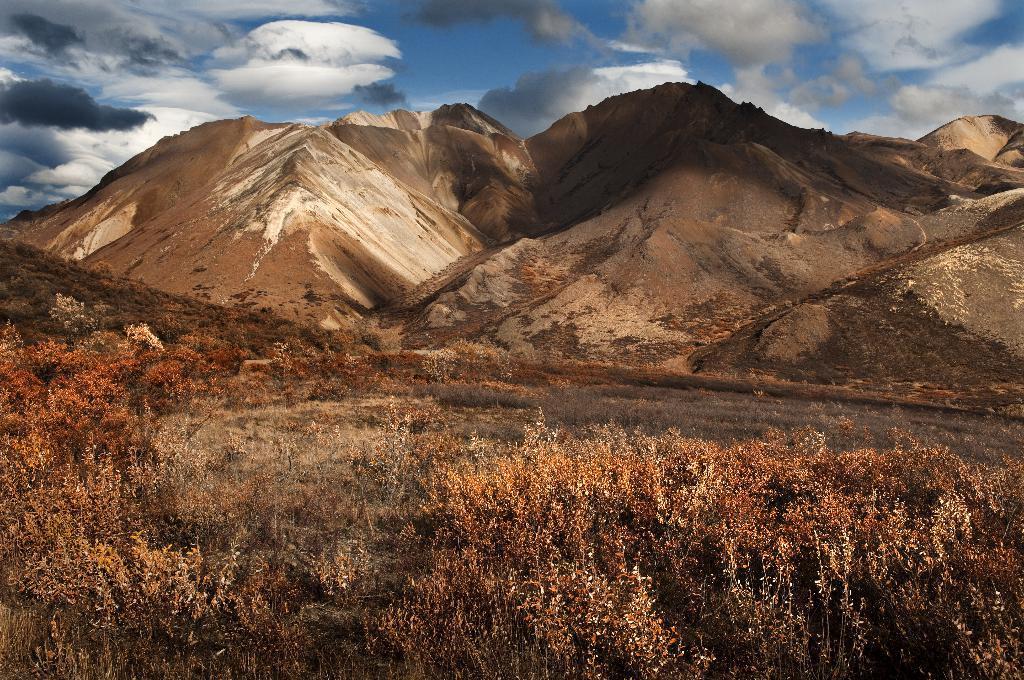Could you give a brief overview of what you see in this image? In this image I can see few trees which are cream, brown and orange in color on the ground and in the background I can see few mountains which are black, brown and cream in color and the sky. 